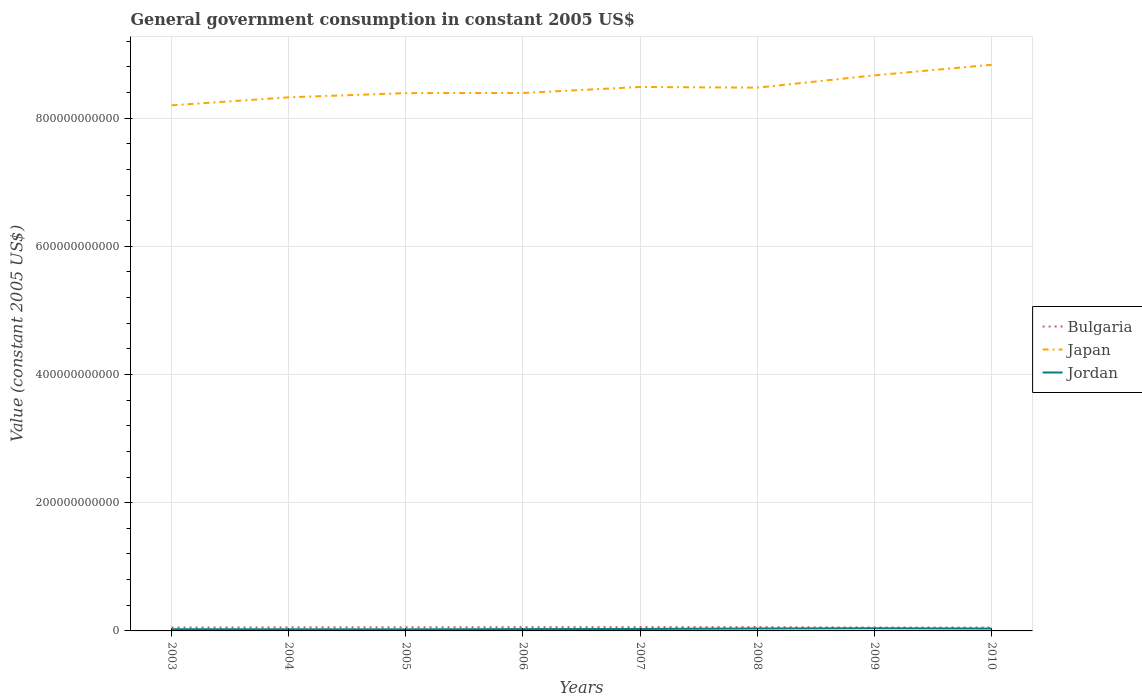Does the line corresponding to Bulgaria intersect with the line corresponding to Japan?
Offer a terse response. No. Is the number of lines equal to the number of legend labels?
Make the answer very short. Yes. Across all years, what is the maximum government conusmption in Bulgaria?
Keep it short and to the point. 5.26e+09. What is the total government conusmption in Japan in the graph?
Give a very brief answer. -1.64e+1. What is the difference between the highest and the second highest government conusmption in Jordan?
Keep it short and to the point. 1.69e+09. What is the difference between the highest and the lowest government conusmption in Japan?
Offer a terse response. 4. Is the government conusmption in Jordan strictly greater than the government conusmption in Bulgaria over the years?
Provide a succinct answer. Yes. What is the difference between two consecutive major ticks on the Y-axis?
Ensure brevity in your answer.  2.00e+11. Are the values on the major ticks of Y-axis written in scientific E-notation?
Offer a very short reply. No. Where does the legend appear in the graph?
Offer a terse response. Center right. What is the title of the graph?
Ensure brevity in your answer.  General government consumption in constant 2005 US$. Does "Georgia" appear as one of the legend labels in the graph?
Provide a short and direct response. No. What is the label or title of the X-axis?
Ensure brevity in your answer.  Years. What is the label or title of the Y-axis?
Your answer should be very brief. Value (constant 2005 US$). What is the Value (constant 2005 US$) of Bulgaria in 2003?
Give a very brief answer. 5.26e+09. What is the Value (constant 2005 US$) of Japan in 2003?
Provide a short and direct response. 8.20e+11. What is the Value (constant 2005 US$) of Jordan in 2003?
Provide a succinct answer. 2.63e+09. What is the Value (constant 2005 US$) of Bulgaria in 2004?
Give a very brief answer. 5.54e+09. What is the Value (constant 2005 US$) of Japan in 2004?
Your answer should be compact. 8.32e+11. What is the Value (constant 2005 US$) of Jordan in 2004?
Provide a succinct answer. 2.52e+09. What is the Value (constant 2005 US$) of Bulgaria in 2005?
Provide a short and direct response. 5.61e+09. What is the Value (constant 2005 US$) of Japan in 2005?
Your response must be concise. 8.39e+11. What is the Value (constant 2005 US$) in Jordan in 2005?
Your answer should be compact. 2.46e+09. What is the Value (constant 2005 US$) of Bulgaria in 2006?
Keep it short and to the point. 5.89e+09. What is the Value (constant 2005 US$) of Japan in 2006?
Your answer should be compact. 8.39e+11. What is the Value (constant 2005 US$) in Jordan in 2006?
Your answer should be very brief. 2.83e+09. What is the Value (constant 2005 US$) of Bulgaria in 2007?
Ensure brevity in your answer.  5.94e+09. What is the Value (constant 2005 US$) of Japan in 2007?
Offer a very short reply. 8.49e+11. What is the Value (constant 2005 US$) in Jordan in 2007?
Provide a succinct answer. 3.04e+09. What is the Value (constant 2005 US$) in Bulgaria in 2008?
Your answer should be very brief. 5.93e+09. What is the Value (constant 2005 US$) of Japan in 2008?
Keep it short and to the point. 8.47e+11. What is the Value (constant 2005 US$) of Jordan in 2008?
Make the answer very short. 3.76e+09. What is the Value (constant 2005 US$) of Bulgaria in 2009?
Make the answer very short. 5.37e+09. What is the Value (constant 2005 US$) in Japan in 2009?
Make the answer very short. 8.67e+11. What is the Value (constant 2005 US$) of Jordan in 2009?
Keep it short and to the point. 4.15e+09. What is the Value (constant 2005 US$) in Bulgaria in 2010?
Provide a succinct answer. 5.27e+09. What is the Value (constant 2005 US$) in Japan in 2010?
Your response must be concise. 8.83e+11. What is the Value (constant 2005 US$) in Jordan in 2010?
Provide a short and direct response. 3.68e+09. Across all years, what is the maximum Value (constant 2005 US$) of Bulgaria?
Ensure brevity in your answer.  5.94e+09. Across all years, what is the maximum Value (constant 2005 US$) in Japan?
Make the answer very short. 8.83e+11. Across all years, what is the maximum Value (constant 2005 US$) of Jordan?
Your response must be concise. 4.15e+09. Across all years, what is the minimum Value (constant 2005 US$) of Bulgaria?
Keep it short and to the point. 5.26e+09. Across all years, what is the minimum Value (constant 2005 US$) in Japan?
Your response must be concise. 8.20e+11. Across all years, what is the minimum Value (constant 2005 US$) of Jordan?
Your answer should be very brief. 2.46e+09. What is the total Value (constant 2005 US$) of Bulgaria in the graph?
Your answer should be very brief. 4.48e+1. What is the total Value (constant 2005 US$) in Japan in the graph?
Give a very brief answer. 6.78e+12. What is the total Value (constant 2005 US$) in Jordan in the graph?
Give a very brief answer. 2.51e+1. What is the difference between the Value (constant 2005 US$) in Bulgaria in 2003 and that in 2004?
Make the answer very short. -2.78e+08. What is the difference between the Value (constant 2005 US$) in Japan in 2003 and that in 2004?
Offer a terse response. -1.25e+1. What is the difference between the Value (constant 2005 US$) in Jordan in 2003 and that in 2004?
Make the answer very short. 1.10e+08. What is the difference between the Value (constant 2005 US$) in Bulgaria in 2003 and that in 2005?
Keep it short and to the point. -3.56e+08. What is the difference between the Value (constant 2005 US$) of Japan in 2003 and that in 2005?
Your response must be concise. -1.90e+1. What is the difference between the Value (constant 2005 US$) in Jordan in 2003 and that in 2005?
Provide a succinct answer. 1.72e+08. What is the difference between the Value (constant 2005 US$) in Bulgaria in 2003 and that in 2006?
Provide a short and direct response. -6.34e+08. What is the difference between the Value (constant 2005 US$) in Japan in 2003 and that in 2006?
Give a very brief answer. -1.93e+1. What is the difference between the Value (constant 2005 US$) in Jordan in 2003 and that in 2006?
Keep it short and to the point. -2.01e+08. What is the difference between the Value (constant 2005 US$) in Bulgaria in 2003 and that in 2007?
Offer a terse response. -6.83e+08. What is the difference between the Value (constant 2005 US$) of Japan in 2003 and that in 2007?
Make the answer very short. -2.86e+1. What is the difference between the Value (constant 2005 US$) in Jordan in 2003 and that in 2007?
Ensure brevity in your answer.  -4.11e+08. What is the difference between the Value (constant 2005 US$) of Bulgaria in 2003 and that in 2008?
Your answer should be compact. -6.74e+08. What is the difference between the Value (constant 2005 US$) in Japan in 2003 and that in 2008?
Your response must be concise. -2.75e+1. What is the difference between the Value (constant 2005 US$) in Jordan in 2003 and that in 2008?
Provide a short and direct response. -1.13e+09. What is the difference between the Value (constant 2005 US$) in Bulgaria in 2003 and that in 2009?
Make the answer very short. -1.13e+08. What is the difference between the Value (constant 2005 US$) of Japan in 2003 and that in 2009?
Your answer should be compact. -4.68e+1. What is the difference between the Value (constant 2005 US$) of Jordan in 2003 and that in 2009?
Provide a succinct answer. -1.52e+09. What is the difference between the Value (constant 2005 US$) of Bulgaria in 2003 and that in 2010?
Your answer should be compact. -8.52e+06. What is the difference between the Value (constant 2005 US$) in Japan in 2003 and that in 2010?
Your response must be concise. -6.32e+1. What is the difference between the Value (constant 2005 US$) in Jordan in 2003 and that in 2010?
Offer a terse response. -1.05e+09. What is the difference between the Value (constant 2005 US$) in Bulgaria in 2004 and that in 2005?
Offer a very short reply. -7.82e+07. What is the difference between the Value (constant 2005 US$) of Japan in 2004 and that in 2005?
Your answer should be compact. -6.57e+09. What is the difference between the Value (constant 2005 US$) in Jordan in 2004 and that in 2005?
Make the answer very short. 6.21e+07. What is the difference between the Value (constant 2005 US$) in Bulgaria in 2004 and that in 2006?
Your answer should be very brief. -3.56e+08. What is the difference between the Value (constant 2005 US$) in Japan in 2004 and that in 2006?
Your answer should be compact. -6.80e+09. What is the difference between the Value (constant 2005 US$) of Jordan in 2004 and that in 2006?
Your answer should be compact. -3.11e+08. What is the difference between the Value (constant 2005 US$) of Bulgaria in 2004 and that in 2007?
Keep it short and to the point. -4.04e+08. What is the difference between the Value (constant 2005 US$) in Japan in 2004 and that in 2007?
Keep it short and to the point. -1.61e+1. What is the difference between the Value (constant 2005 US$) in Jordan in 2004 and that in 2007?
Give a very brief answer. -5.21e+08. What is the difference between the Value (constant 2005 US$) in Bulgaria in 2004 and that in 2008?
Provide a succinct answer. -3.95e+08. What is the difference between the Value (constant 2005 US$) in Japan in 2004 and that in 2008?
Your response must be concise. -1.51e+1. What is the difference between the Value (constant 2005 US$) of Jordan in 2004 and that in 2008?
Offer a terse response. -1.24e+09. What is the difference between the Value (constant 2005 US$) in Bulgaria in 2004 and that in 2009?
Offer a very short reply. 1.65e+08. What is the difference between the Value (constant 2005 US$) in Japan in 2004 and that in 2009?
Provide a short and direct response. -3.43e+1. What is the difference between the Value (constant 2005 US$) of Jordan in 2004 and that in 2009?
Give a very brief answer. -1.63e+09. What is the difference between the Value (constant 2005 US$) of Bulgaria in 2004 and that in 2010?
Keep it short and to the point. 2.70e+08. What is the difference between the Value (constant 2005 US$) in Japan in 2004 and that in 2010?
Provide a short and direct response. -5.07e+1. What is the difference between the Value (constant 2005 US$) of Jordan in 2004 and that in 2010?
Give a very brief answer. -1.16e+09. What is the difference between the Value (constant 2005 US$) in Bulgaria in 2005 and that in 2006?
Your response must be concise. -2.78e+08. What is the difference between the Value (constant 2005 US$) in Japan in 2005 and that in 2006?
Provide a short and direct response. -2.30e+08. What is the difference between the Value (constant 2005 US$) in Jordan in 2005 and that in 2006?
Give a very brief answer. -3.73e+08. What is the difference between the Value (constant 2005 US$) of Bulgaria in 2005 and that in 2007?
Your answer should be very brief. -3.26e+08. What is the difference between the Value (constant 2005 US$) in Japan in 2005 and that in 2007?
Give a very brief answer. -9.56e+09. What is the difference between the Value (constant 2005 US$) in Jordan in 2005 and that in 2007?
Your answer should be compact. -5.83e+08. What is the difference between the Value (constant 2005 US$) of Bulgaria in 2005 and that in 2008?
Provide a succinct answer. -3.17e+08. What is the difference between the Value (constant 2005 US$) in Japan in 2005 and that in 2008?
Provide a short and direct response. -8.49e+09. What is the difference between the Value (constant 2005 US$) of Jordan in 2005 and that in 2008?
Offer a terse response. -1.30e+09. What is the difference between the Value (constant 2005 US$) of Bulgaria in 2005 and that in 2009?
Make the answer very short. 2.44e+08. What is the difference between the Value (constant 2005 US$) in Japan in 2005 and that in 2009?
Give a very brief answer. -2.77e+1. What is the difference between the Value (constant 2005 US$) in Jordan in 2005 and that in 2009?
Make the answer very short. -1.69e+09. What is the difference between the Value (constant 2005 US$) in Bulgaria in 2005 and that in 2010?
Offer a terse response. 3.48e+08. What is the difference between the Value (constant 2005 US$) in Japan in 2005 and that in 2010?
Make the answer very short. -4.42e+1. What is the difference between the Value (constant 2005 US$) in Jordan in 2005 and that in 2010?
Make the answer very short. -1.22e+09. What is the difference between the Value (constant 2005 US$) in Bulgaria in 2006 and that in 2007?
Provide a succinct answer. -4.85e+07. What is the difference between the Value (constant 2005 US$) in Japan in 2006 and that in 2007?
Your response must be concise. -9.33e+09. What is the difference between the Value (constant 2005 US$) in Jordan in 2006 and that in 2007?
Provide a succinct answer. -2.10e+08. What is the difference between the Value (constant 2005 US$) of Bulgaria in 2006 and that in 2008?
Offer a very short reply. -3.97e+07. What is the difference between the Value (constant 2005 US$) in Japan in 2006 and that in 2008?
Offer a terse response. -8.26e+09. What is the difference between the Value (constant 2005 US$) in Jordan in 2006 and that in 2008?
Your answer should be very brief. -9.28e+08. What is the difference between the Value (constant 2005 US$) in Bulgaria in 2006 and that in 2009?
Give a very brief answer. 5.21e+08. What is the difference between the Value (constant 2005 US$) of Japan in 2006 and that in 2009?
Ensure brevity in your answer.  -2.75e+1. What is the difference between the Value (constant 2005 US$) of Jordan in 2006 and that in 2009?
Offer a terse response. -1.32e+09. What is the difference between the Value (constant 2005 US$) in Bulgaria in 2006 and that in 2010?
Your response must be concise. 6.25e+08. What is the difference between the Value (constant 2005 US$) of Japan in 2006 and that in 2010?
Provide a short and direct response. -4.39e+1. What is the difference between the Value (constant 2005 US$) in Jordan in 2006 and that in 2010?
Offer a very short reply. -8.51e+08. What is the difference between the Value (constant 2005 US$) in Bulgaria in 2007 and that in 2008?
Ensure brevity in your answer.  8.86e+06. What is the difference between the Value (constant 2005 US$) in Japan in 2007 and that in 2008?
Ensure brevity in your answer.  1.07e+09. What is the difference between the Value (constant 2005 US$) in Jordan in 2007 and that in 2008?
Your answer should be compact. -7.18e+08. What is the difference between the Value (constant 2005 US$) in Bulgaria in 2007 and that in 2009?
Keep it short and to the point. 5.70e+08. What is the difference between the Value (constant 2005 US$) in Japan in 2007 and that in 2009?
Ensure brevity in your answer.  -1.82e+1. What is the difference between the Value (constant 2005 US$) in Jordan in 2007 and that in 2009?
Provide a short and direct response. -1.11e+09. What is the difference between the Value (constant 2005 US$) of Bulgaria in 2007 and that in 2010?
Give a very brief answer. 6.74e+08. What is the difference between the Value (constant 2005 US$) in Japan in 2007 and that in 2010?
Offer a very short reply. -3.46e+1. What is the difference between the Value (constant 2005 US$) in Jordan in 2007 and that in 2010?
Your answer should be very brief. -6.41e+08. What is the difference between the Value (constant 2005 US$) in Bulgaria in 2008 and that in 2009?
Ensure brevity in your answer.  5.61e+08. What is the difference between the Value (constant 2005 US$) in Japan in 2008 and that in 2009?
Your answer should be compact. -1.92e+1. What is the difference between the Value (constant 2005 US$) in Jordan in 2008 and that in 2009?
Your answer should be compact. -3.93e+08. What is the difference between the Value (constant 2005 US$) in Bulgaria in 2008 and that in 2010?
Offer a terse response. 6.65e+08. What is the difference between the Value (constant 2005 US$) in Japan in 2008 and that in 2010?
Give a very brief answer. -3.57e+1. What is the difference between the Value (constant 2005 US$) in Jordan in 2008 and that in 2010?
Make the answer very short. 7.65e+07. What is the difference between the Value (constant 2005 US$) in Bulgaria in 2009 and that in 2010?
Provide a short and direct response. 1.04e+08. What is the difference between the Value (constant 2005 US$) of Japan in 2009 and that in 2010?
Ensure brevity in your answer.  -1.64e+1. What is the difference between the Value (constant 2005 US$) of Jordan in 2009 and that in 2010?
Offer a very short reply. 4.69e+08. What is the difference between the Value (constant 2005 US$) in Bulgaria in 2003 and the Value (constant 2005 US$) in Japan in 2004?
Make the answer very short. -8.27e+11. What is the difference between the Value (constant 2005 US$) in Bulgaria in 2003 and the Value (constant 2005 US$) in Jordan in 2004?
Make the answer very short. 2.74e+09. What is the difference between the Value (constant 2005 US$) of Japan in 2003 and the Value (constant 2005 US$) of Jordan in 2004?
Offer a very short reply. 8.17e+11. What is the difference between the Value (constant 2005 US$) of Bulgaria in 2003 and the Value (constant 2005 US$) of Japan in 2005?
Your answer should be compact. -8.34e+11. What is the difference between the Value (constant 2005 US$) in Bulgaria in 2003 and the Value (constant 2005 US$) in Jordan in 2005?
Make the answer very short. 2.80e+09. What is the difference between the Value (constant 2005 US$) in Japan in 2003 and the Value (constant 2005 US$) in Jordan in 2005?
Your response must be concise. 8.17e+11. What is the difference between the Value (constant 2005 US$) of Bulgaria in 2003 and the Value (constant 2005 US$) of Japan in 2006?
Keep it short and to the point. -8.34e+11. What is the difference between the Value (constant 2005 US$) of Bulgaria in 2003 and the Value (constant 2005 US$) of Jordan in 2006?
Offer a terse response. 2.43e+09. What is the difference between the Value (constant 2005 US$) in Japan in 2003 and the Value (constant 2005 US$) in Jordan in 2006?
Provide a short and direct response. 8.17e+11. What is the difference between the Value (constant 2005 US$) in Bulgaria in 2003 and the Value (constant 2005 US$) in Japan in 2007?
Provide a succinct answer. -8.43e+11. What is the difference between the Value (constant 2005 US$) of Bulgaria in 2003 and the Value (constant 2005 US$) of Jordan in 2007?
Provide a short and direct response. 2.22e+09. What is the difference between the Value (constant 2005 US$) of Japan in 2003 and the Value (constant 2005 US$) of Jordan in 2007?
Provide a short and direct response. 8.17e+11. What is the difference between the Value (constant 2005 US$) of Bulgaria in 2003 and the Value (constant 2005 US$) of Japan in 2008?
Provide a succinct answer. -8.42e+11. What is the difference between the Value (constant 2005 US$) in Bulgaria in 2003 and the Value (constant 2005 US$) in Jordan in 2008?
Your answer should be compact. 1.50e+09. What is the difference between the Value (constant 2005 US$) in Japan in 2003 and the Value (constant 2005 US$) in Jordan in 2008?
Provide a short and direct response. 8.16e+11. What is the difference between the Value (constant 2005 US$) in Bulgaria in 2003 and the Value (constant 2005 US$) in Japan in 2009?
Offer a very short reply. -8.61e+11. What is the difference between the Value (constant 2005 US$) in Bulgaria in 2003 and the Value (constant 2005 US$) in Jordan in 2009?
Ensure brevity in your answer.  1.11e+09. What is the difference between the Value (constant 2005 US$) of Japan in 2003 and the Value (constant 2005 US$) of Jordan in 2009?
Keep it short and to the point. 8.16e+11. What is the difference between the Value (constant 2005 US$) in Bulgaria in 2003 and the Value (constant 2005 US$) in Japan in 2010?
Make the answer very short. -8.78e+11. What is the difference between the Value (constant 2005 US$) of Bulgaria in 2003 and the Value (constant 2005 US$) of Jordan in 2010?
Ensure brevity in your answer.  1.58e+09. What is the difference between the Value (constant 2005 US$) in Japan in 2003 and the Value (constant 2005 US$) in Jordan in 2010?
Your answer should be compact. 8.16e+11. What is the difference between the Value (constant 2005 US$) in Bulgaria in 2004 and the Value (constant 2005 US$) in Japan in 2005?
Give a very brief answer. -8.33e+11. What is the difference between the Value (constant 2005 US$) of Bulgaria in 2004 and the Value (constant 2005 US$) of Jordan in 2005?
Your answer should be compact. 3.08e+09. What is the difference between the Value (constant 2005 US$) in Japan in 2004 and the Value (constant 2005 US$) in Jordan in 2005?
Your response must be concise. 8.30e+11. What is the difference between the Value (constant 2005 US$) in Bulgaria in 2004 and the Value (constant 2005 US$) in Japan in 2006?
Your response must be concise. -8.34e+11. What is the difference between the Value (constant 2005 US$) of Bulgaria in 2004 and the Value (constant 2005 US$) of Jordan in 2006?
Provide a succinct answer. 2.70e+09. What is the difference between the Value (constant 2005 US$) of Japan in 2004 and the Value (constant 2005 US$) of Jordan in 2006?
Offer a very short reply. 8.30e+11. What is the difference between the Value (constant 2005 US$) in Bulgaria in 2004 and the Value (constant 2005 US$) in Japan in 2007?
Make the answer very short. -8.43e+11. What is the difference between the Value (constant 2005 US$) of Bulgaria in 2004 and the Value (constant 2005 US$) of Jordan in 2007?
Your answer should be very brief. 2.49e+09. What is the difference between the Value (constant 2005 US$) in Japan in 2004 and the Value (constant 2005 US$) in Jordan in 2007?
Your answer should be compact. 8.29e+11. What is the difference between the Value (constant 2005 US$) of Bulgaria in 2004 and the Value (constant 2005 US$) of Japan in 2008?
Offer a terse response. -8.42e+11. What is the difference between the Value (constant 2005 US$) in Bulgaria in 2004 and the Value (constant 2005 US$) in Jordan in 2008?
Provide a short and direct response. 1.78e+09. What is the difference between the Value (constant 2005 US$) in Japan in 2004 and the Value (constant 2005 US$) in Jordan in 2008?
Your answer should be compact. 8.29e+11. What is the difference between the Value (constant 2005 US$) of Bulgaria in 2004 and the Value (constant 2005 US$) of Japan in 2009?
Your answer should be compact. -8.61e+11. What is the difference between the Value (constant 2005 US$) of Bulgaria in 2004 and the Value (constant 2005 US$) of Jordan in 2009?
Provide a short and direct response. 1.38e+09. What is the difference between the Value (constant 2005 US$) of Japan in 2004 and the Value (constant 2005 US$) of Jordan in 2009?
Give a very brief answer. 8.28e+11. What is the difference between the Value (constant 2005 US$) of Bulgaria in 2004 and the Value (constant 2005 US$) of Japan in 2010?
Offer a terse response. -8.78e+11. What is the difference between the Value (constant 2005 US$) in Bulgaria in 2004 and the Value (constant 2005 US$) in Jordan in 2010?
Provide a short and direct response. 1.85e+09. What is the difference between the Value (constant 2005 US$) of Japan in 2004 and the Value (constant 2005 US$) of Jordan in 2010?
Provide a succinct answer. 8.29e+11. What is the difference between the Value (constant 2005 US$) in Bulgaria in 2005 and the Value (constant 2005 US$) in Japan in 2006?
Your answer should be very brief. -8.34e+11. What is the difference between the Value (constant 2005 US$) in Bulgaria in 2005 and the Value (constant 2005 US$) in Jordan in 2006?
Provide a short and direct response. 2.78e+09. What is the difference between the Value (constant 2005 US$) in Japan in 2005 and the Value (constant 2005 US$) in Jordan in 2006?
Offer a terse response. 8.36e+11. What is the difference between the Value (constant 2005 US$) in Bulgaria in 2005 and the Value (constant 2005 US$) in Japan in 2007?
Make the answer very short. -8.43e+11. What is the difference between the Value (constant 2005 US$) of Bulgaria in 2005 and the Value (constant 2005 US$) of Jordan in 2007?
Your response must be concise. 2.57e+09. What is the difference between the Value (constant 2005 US$) in Japan in 2005 and the Value (constant 2005 US$) in Jordan in 2007?
Your response must be concise. 8.36e+11. What is the difference between the Value (constant 2005 US$) of Bulgaria in 2005 and the Value (constant 2005 US$) of Japan in 2008?
Give a very brief answer. -8.42e+11. What is the difference between the Value (constant 2005 US$) in Bulgaria in 2005 and the Value (constant 2005 US$) in Jordan in 2008?
Offer a very short reply. 1.86e+09. What is the difference between the Value (constant 2005 US$) of Japan in 2005 and the Value (constant 2005 US$) of Jordan in 2008?
Offer a terse response. 8.35e+11. What is the difference between the Value (constant 2005 US$) of Bulgaria in 2005 and the Value (constant 2005 US$) of Japan in 2009?
Offer a terse response. -8.61e+11. What is the difference between the Value (constant 2005 US$) of Bulgaria in 2005 and the Value (constant 2005 US$) of Jordan in 2009?
Your response must be concise. 1.46e+09. What is the difference between the Value (constant 2005 US$) in Japan in 2005 and the Value (constant 2005 US$) in Jordan in 2009?
Provide a short and direct response. 8.35e+11. What is the difference between the Value (constant 2005 US$) of Bulgaria in 2005 and the Value (constant 2005 US$) of Japan in 2010?
Your response must be concise. -8.77e+11. What is the difference between the Value (constant 2005 US$) in Bulgaria in 2005 and the Value (constant 2005 US$) in Jordan in 2010?
Your response must be concise. 1.93e+09. What is the difference between the Value (constant 2005 US$) of Japan in 2005 and the Value (constant 2005 US$) of Jordan in 2010?
Make the answer very short. 8.35e+11. What is the difference between the Value (constant 2005 US$) in Bulgaria in 2006 and the Value (constant 2005 US$) in Japan in 2007?
Ensure brevity in your answer.  -8.43e+11. What is the difference between the Value (constant 2005 US$) of Bulgaria in 2006 and the Value (constant 2005 US$) of Jordan in 2007?
Provide a short and direct response. 2.85e+09. What is the difference between the Value (constant 2005 US$) of Japan in 2006 and the Value (constant 2005 US$) of Jordan in 2007?
Your answer should be compact. 8.36e+11. What is the difference between the Value (constant 2005 US$) of Bulgaria in 2006 and the Value (constant 2005 US$) of Japan in 2008?
Keep it short and to the point. -8.42e+11. What is the difference between the Value (constant 2005 US$) in Bulgaria in 2006 and the Value (constant 2005 US$) in Jordan in 2008?
Your answer should be compact. 2.13e+09. What is the difference between the Value (constant 2005 US$) in Japan in 2006 and the Value (constant 2005 US$) in Jordan in 2008?
Ensure brevity in your answer.  8.35e+11. What is the difference between the Value (constant 2005 US$) of Bulgaria in 2006 and the Value (constant 2005 US$) of Japan in 2009?
Provide a short and direct response. -8.61e+11. What is the difference between the Value (constant 2005 US$) in Bulgaria in 2006 and the Value (constant 2005 US$) in Jordan in 2009?
Provide a short and direct response. 1.74e+09. What is the difference between the Value (constant 2005 US$) of Japan in 2006 and the Value (constant 2005 US$) of Jordan in 2009?
Provide a succinct answer. 8.35e+11. What is the difference between the Value (constant 2005 US$) of Bulgaria in 2006 and the Value (constant 2005 US$) of Japan in 2010?
Your answer should be compact. -8.77e+11. What is the difference between the Value (constant 2005 US$) of Bulgaria in 2006 and the Value (constant 2005 US$) of Jordan in 2010?
Your answer should be compact. 2.21e+09. What is the difference between the Value (constant 2005 US$) of Japan in 2006 and the Value (constant 2005 US$) of Jordan in 2010?
Give a very brief answer. 8.36e+11. What is the difference between the Value (constant 2005 US$) of Bulgaria in 2007 and the Value (constant 2005 US$) of Japan in 2008?
Provide a succinct answer. -8.41e+11. What is the difference between the Value (constant 2005 US$) in Bulgaria in 2007 and the Value (constant 2005 US$) in Jordan in 2008?
Make the answer very short. 2.18e+09. What is the difference between the Value (constant 2005 US$) of Japan in 2007 and the Value (constant 2005 US$) of Jordan in 2008?
Offer a terse response. 8.45e+11. What is the difference between the Value (constant 2005 US$) in Bulgaria in 2007 and the Value (constant 2005 US$) in Japan in 2009?
Keep it short and to the point. -8.61e+11. What is the difference between the Value (constant 2005 US$) in Bulgaria in 2007 and the Value (constant 2005 US$) in Jordan in 2009?
Your answer should be compact. 1.79e+09. What is the difference between the Value (constant 2005 US$) in Japan in 2007 and the Value (constant 2005 US$) in Jordan in 2009?
Keep it short and to the point. 8.44e+11. What is the difference between the Value (constant 2005 US$) of Bulgaria in 2007 and the Value (constant 2005 US$) of Japan in 2010?
Give a very brief answer. -8.77e+11. What is the difference between the Value (constant 2005 US$) of Bulgaria in 2007 and the Value (constant 2005 US$) of Jordan in 2010?
Offer a terse response. 2.26e+09. What is the difference between the Value (constant 2005 US$) of Japan in 2007 and the Value (constant 2005 US$) of Jordan in 2010?
Keep it short and to the point. 8.45e+11. What is the difference between the Value (constant 2005 US$) of Bulgaria in 2008 and the Value (constant 2005 US$) of Japan in 2009?
Your response must be concise. -8.61e+11. What is the difference between the Value (constant 2005 US$) in Bulgaria in 2008 and the Value (constant 2005 US$) in Jordan in 2009?
Your answer should be very brief. 1.78e+09. What is the difference between the Value (constant 2005 US$) of Japan in 2008 and the Value (constant 2005 US$) of Jordan in 2009?
Make the answer very short. 8.43e+11. What is the difference between the Value (constant 2005 US$) of Bulgaria in 2008 and the Value (constant 2005 US$) of Japan in 2010?
Keep it short and to the point. -8.77e+11. What is the difference between the Value (constant 2005 US$) of Bulgaria in 2008 and the Value (constant 2005 US$) of Jordan in 2010?
Your answer should be compact. 2.25e+09. What is the difference between the Value (constant 2005 US$) in Japan in 2008 and the Value (constant 2005 US$) in Jordan in 2010?
Your answer should be compact. 8.44e+11. What is the difference between the Value (constant 2005 US$) in Bulgaria in 2009 and the Value (constant 2005 US$) in Japan in 2010?
Offer a terse response. -8.78e+11. What is the difference between the Value (constant 2005 US$) in Bulgaria in 2009 and the Value (constant 2005 US$) in Jordan in 2010?
Provide a succinct answer. 1.69e+09. What is the difference between the Value (constant 2005 US$) in Japan in 2009 and the Value (constant 2005 US$) in Jordan in 2010?
Provide a short and direct response. 8.63e+11. What is the average Value (constant 2005 US$) of Bulgaria per year?
Your answer should be compact. 5.60e+09. What is the average Value (constant 2005 US$) of Japan per year?
Make the answer very short. 8.47e+11. What is the average Value (constant 2005 US$) in Jordan per year?
Ensure brevity in your answer.  3.13e+09. In the year 2003, what is the difference between the Value (constant 2005 US$) of Bulgaria and Value (constant 2005 US$) of Japan?
Your response must be concise. -8.15e+11. In the year 2003, what is the difference between the Value (constant 2005 US$) in Bulgaria and Value (constant 2005 US$) in Jordan?
Ensure brevity in your answer.  2.63e+09. In the year 2003, what is the difference between the Value (constant 2005 US$) of Japan and Value (constant 2005 US$) of Jordan?
Offer a very short reply. 8.17e+11. In the year 2004, what is the difference between the Value (constant 2005 US$) in Bulgaria and Value (constant 2005 US$) in Japan?
Ensure brevity in your answer.  -8.27e+11. In the year 2004, what is the difference between the Value (constant 2005 US$) in Bulgaria and Value (constant 2005 US$) in Jordan?
Keep it short and to the point. 3.02e+09. In the year 2004, what is the difference between the Value (constant 2005 US$) in Japan and Value (constant 2005 US$) in Jordan?
Provide a succinct answer. 8.30e+11. In the year 2005, what is the difference between the Value (constant 2005 US$) of Bulgaria and Value (constant 2005 US$) of Japan?
Give a very brief answer. -8.33e+11. In the year 2005, what is the difference between the Value (constant 2005 US$) in Bulgaria and Value (constant 2005 US$) in Jordan?
Your answer should be compact. 3.16e+09. In the year 2005, what is the difference between the Value (constant 2005 US$) of Japan and Value (constant 2005 US$) of Jordan?
Your response must be concise. 8.36e+11. In the year 2006, what is the difference between the Value (constant 2005 US$) of Bulgaria and Value (constant 2005 US$) of Japan?
Offer a terse response. -8.33e+11. In the year 2006, what is the difference between the Value (constant 2005 US$) of Bulgaria and Value (constant 2005 US$) of Jordan?
Offer a very short reply. 3.06e+09. In the year 2006, what is the difference between the Value (constant 2005 US$) of Japan and Value (constant 2005 US$) of Jordan?
Your answer should be compact. 8.36e+11. In the year 2007, what is the difference between the Value (constant 2005 US$) of Bulgaria and Value (constant 2005 US$) of Japan?
Your response must be concise. -8.43e+11. In the year 2007, what is the difference between the Value (constant 2005 US$) in Bulgaria and Value (constant 2005 US$) in Jordan?
Your answer should be compact. 2.90e+09. In the year 2007, what is the difference between the Value (constant 2005 US$) in Japan and Value (constant 2005 US$) in Jordan?
Offer a very short reply. 8.45e+11. In the year 2008, what is the difference between the Value (constant 2005 US$) in Bulgaria and Value (constant 2005 US$) in Japan?
Your response must be concise. -8.42e+11. In the year 2008, what is the difference between the Value (constant 2005 US$) in Bulgaria and Value (constant 2005 US$) in Jordan?
Offer a terse response. 2.17e+09. In the year 2008, what is the difference between the Value (constant 2005 US$) of Japan and Value (constant 2005 US$) of Jordan?
Your answer should be very brief. 8.44e+11. In the year 2009, what is the difference between the Value (constant 2005 US$) of Bulgaria and Value (constant 2005 US$) of Japan?
Your answer should be very brief. -8.61e+11. In the year 2009, what is the difference between the Value (constant 2005 US$) in Bulgaria and Value (constant 2005 US$) in Jordan?
Keep it short and to the point. 1.22e+09. In the year 2009, what is the difference between the Value (constant 2005 US$) of Japan and Value (constant 2005 US$) of Jordan?
Offer a terse response. 8.63e+11. In the year 2010, what is the difference between the Value (constant 2005 US$) in Bulgaria and Value (constant 2005 US$) in Japan?
Offer a very short reply. -8.78e+11. In the year 2010, what is the difference between the Value (constant 2005 US$) of Bulgaria and Value (constant 2005 US$) of Jordan?
Offer a terse response. 1.58e+09. In the year 2010, what is the difference between the Value (constant 2005 US$) in Japan and Value (constant 2005 US$) in Jordan?
Ensure brevity in your answer.  8.79e+11. What is the ratio of the Value (constant 2005 US$) in Bulgaria in 2003 to that in 2004?
Provide a succinct answer. 0.95. What is the ratio of the Value (constant 2005 US$) of Japan in 2003 to that in 2004?
Provide a short and direct response. 0.98. What is the ratio of the Value (constant 2005 US$) in Jordan in 2003 to that in 2004?
Offer a terse response. 1.04. What is the ratio of the Value (constant 2005 US$) of Bulgaria in 2003 to that in 2005?
Offer a very short reply. 0.94. What is the ratio of the Value (constant 2005 US$) of Japan in 2003 to that in 2005?
Keep it short and to the point. 0.98. What is the ratio of the Value (constant 2005 US$) in Jordan in 2003 to that in 2005?
Offer a very short reply. 1.07. What is the ratio of the Value (constant 2005 US$) in Bulgaria in 2003 to that in 2006?
Make the answer very short. 0.89. What is the ratio of the Value (constant 2005 US$) of Jordan in 2003 to that in 2006?
Make the answer very short. 0.93. What is the ratio of the Value (constant 2005 US$) of Bulgaria in 2003 to that in 2007?
Give a very brief answer. 0.89. What is the ratio of the Value (constant 2005 US$) in Japan in 2003 to that in 2007?
Your response must be concise. 0.97. What is the ratio of the Value (constant 2005 US$) of Jordan in 2003 to that in 2007?
Your answer should be very brief. 0.86. What is the ratio of the Value (constant 2005 US$) of Bulgaria in 2003 to that in 2008?
Provide a short and direct response. 0.89. What is the ratio of the Value (constant 2005 US$) of Japan in 2003 to that in 2008?
Keep it short and to the point. 0.97. What is the ratio of the Value (constant 2005 US$) of Jordan in 2003 to that in 2008?
Your response must be concise. 0.7. What is the ratio of the Value (constant 2005 US$) in Japan in 2003 to that in 2009?
Your answer should be compact. 0.95. What is the ratio of the Value (constant 2005 US$) of Jordan in 2003 to that in 2009?
Provide a succinct answer. 0.63. What is the ratio of the Value (constant 2005 US$) of Bulgaria in 2003 to that in 2010?
Ensure brevity in your answer.  1. What is the ratio of the Value (constant 2005 US$) in Japan in 2003 to that in 2010?
Keep it short and to the point. 0.93. What is the ratio of the Value (constant 2005 US$) in Jordan in 2003 to that in 2010?
Your answer should be very brief. 0.71. What is the ratio of the Value (constant 2005 US$) of Bulgaria in 2004 to that in 2005?
Give a very brief answer. 0.99. What is the ratio of the Value (constant 2005 US$) of Japan in 2004 to that in 2005?
Ensure brevity in your answer.  0.99. What is the ratio of the Value (constant 2005 US$) in Jordan in 2004 to that in 2005?
Make the answer very short. 1.03. What is the ratio of the Value (constant 2005 US$) of Bulgaria in 2004 to that in 2006?
Your answer should be compact. 0.94. What is the ratio of the Value (constant 2005 US$) of Jordan in 2004 to that in 2006?
Your answer should be very brief. 0.89. What is the ratio of the Value (constant 2005 US$) of Bulgaria in 2004 to that in 2007?
Your answer should be very brief. 0.93. What is the ratio of the Value (constant 2005 US$) of Jordan in 2004 to that in 2007?
Provide a short and direct response. 0.83. What is the ratio of the Value (constant 2005 US$) of Bulgaria in 2004 to that in 2008?
Ensure brevity in your answer.  0.93. What is the ratio of the Value (constant 2005 US$) in Japan in 2004 to that in 2008?
Provide a short and direct response. 0.98. What is the ratio of the Value (constant 2005 US$) in Jordan in 2004 to that in 2008?
Your answer should be compact. 0.67. What is the ratio of the Value (constant 2005 US$) of Bulgaria in 2004 to that in 2009?
Offer a very short reply. 1.03. What is the ratio of the Value (constant 2005 US$) of Japan in 2004 to that in 2009?
Provide a short and direct response. 0.96. What is the ratio of the Value (constant 2005 US$) of Jordan in 2004 to that in 2009?
Ensure brevity in your answer.  0.61. What is the ratio of the Value (constant 2005 US$) of Bulgaria in 2004 to that in 2010?
Offer a terse response. 1.05. What is the ratio of the Value (constant 2005 US$) of Japan in 2004 to that in 2010?
Offer a terse response. 0.94. What is the ratio of the Value (constant 2005 US$) of Jordan in 2004 to that in 2010?
Provide a short and direct response. 0.68. What is the ratio of the Value (constant 2005 US$) in Bulgaria in 2005 to that in 2006?
Offer a very short reply. 0.95. What is the ratio of the Value (constant 2005 US$) of Japan in 2005 to that in 2006?
Your answer should be compact. 1. What is the ratio of the Value (constant 2005 US$) in Jordan in 2005 to that in 2006?
Your answer should be compact. 0.87. What is the ratio of the Value (constant 2005 US$) in Bulgaria in 2005 to that in 2007?
Your answer should be very brief. 0.95. What is the ratio of the Value (constant 2005 US$) in Japan in 2005 to that in 2007?
Your answer should be compact. 0.99. What is the ratio of the Value (constant 2005 US$) of Jordan in 2005 to that in 2007?
Offer a terse response. 0.81. What is the ratio of the Value (constant 2005 US$) in Bulgaria in 2005 to that in 2008?
Give a very brief answer. 0.95. What is the ratio of the Value (constant 2005 US$) in Japan in 2005 to that in 2008?
Your answer should be very brief. 0.99. What is the ratio of the Value (constant 2005 US$) of Jordan in 2005 to that in 2008?
Your answer should be compact. 0.65. What is the ratio of the Value (constant 2005 US$) in Bulgaria in 2005 to that in 2009?
Offer a very short reply. 1.05. What is the ratio of the Value (constant 2005 US$) in Jordan in 2005 to that in 2009?
Offer a terse response. 0.59. What is the ratio of the Value (constant 2005 US$) of Bulgaria in 2005 to that in 2010?
Provide a short and direct response. 1.07. What is the ratio of the Value (constant 2005 US$) in Jordan in 2005 to that in 2010?
Give a very brief answer. 0.67. What is the ratio of the Value (constant 2005 US$) of Japan in 2006 to that in 2007?
Keep it short and to the point. 0.99. What is the ratio of the Value (constant 2005 US$) in Jordan in 2006 to that in 2007?
Keep it short and to the point. 0.93. What is the ratio of the Value (constant 2005 US$) in Japan in 2006 to that in 2008?
Your answer should be compact. 0.99. What is the ratio of the Value (constant 2005 US$) in Jordan in 2006 to that in 2008?
Make the answer very short. 0.75. What is the ratio of the Value (constant 2005 US$) of Bulgaria in 2006 to that in 2009?
Provide a short and direct response. 1.1. What is the ratio of the Value (constant 2005 US$) in Japan in 2006 to that in 2009?
Offer a terse response. 0.97. What is the ratio of the Value (constant 2005 US$) in Jordan in 2006 to that in 2009?
Offer a terse response. 0.68. What is the ratio of the Value (constant 2005 US$) of Bulgaria in 2006 to that in 2010?
Provide a succinct answer. 1.12. What is the ratio of the Value (constant 2005 US$) of Japan in 2006 to that in 2010?
Offer a terse response. 0.95. What is the ratio of the Value (constant 2005 US$) in Jordan in 2006 to that in 2010?
Keep it short and to the point. 0.77. What is the ratio of the Value (constant 2005 US$) in Japan in 2007 to that in 2008?
Keep it short and to the point. 1. What is the ratio of the Value (constant 2005 US$) of Jordan in 2007 to that in 2008?
Ensure brevity in your answer.  0.81. What is the ratio of the Value (constant 2005 US$) in Bulgaria in 2007 to that in 2009?
Provide a succinct answer. 1.11. What is the ratio of the Value (constant 2005 US$) in Japan in 2007 to that in 2009?
Provide a succinct answer. 0.98. What is the ratio of the Value (constant 2005 US$) of Jordan in 2007 to that in 2009?
Provide a short and direct response. 0.73. What is the ratio of the Value (constant 2005 US$) in Bulgaria in 2007 to that in 2010?
Provide a succinct answer. 1.13. What is the ratio of the Value (constant 2005 US$) of Japan in 2007 to that in 2010?
Your answer should be compact. 0.96. What is the ratio of the Value (constant 2005 US$) of Jordan in 2007 to that in 2010?
Keep it short and to the point. 0.83. What is the ratio of the Value (constant 2005 US$) of Bulgaria in 2008 to that in 2009?
Give a very brief answer. 1.1. What is the ratio of the Value (constant 2005 US$) in Japan in 2008 to that in 2009?
Provide a short and direct response. 0.98. What is the ratio of the Value (constant 2005 US$) in Jordan in 2008 to that in 2009?
Your response must be concise. 0.91. What is the ratio of the Value (constant 2005 US$) of Bulgaria in 2008 to that in 2010?
Make the answer very short. 1.13. What is the ratio of the Value (constant 2005 US$) in Japan in 2008 to that in 2010?
Ensure brevity in your answer.  0.96. What is the ratio of the Value (constant 2005 US$) in Jordan in 2008 to that in 2010?
Your answer should be very brief. 1.02. What is the ratio of the Value (constant 2005 US$) of Bulgaria in 2009 to that in 2010?
Offer a terse response. 1.02. What is the ratio of the Value (constant 2005 US$) of Japan in 2009 to that in 2010?
Offer a very short reply. 0.98. What is the ratio of the Value (constant 2005 US$) of Jordan in 2009 to that in 2010?
Provide a short and direct response. 1.13. What is the difference between the highest and the second highest Value (constant 2005 US$) in Bulgaria?
Make the answer very short. 8.86e+06. What is the difference between the highest and the second highest Value (constant 2005 US$) of Japan?
Offer a very short reply. 1.64e+1. What is the difference between the highest and the second highest Value (constant 2005 US$) of Jordan?
Your response must be concise. 3.93e+08. What is the difference between the highest and the lowest Value (constant 2005 US$) of Bulgaria?
Your answer should be very brief. 6.83e+08. What is the difference between the highest and the lowest Value (constant 2005 US$) in Japan?
Your answer should be compact. 6.32e+1. What is the difference between the highest and the lowest Value (constant 2005 US$) of Jordan?
Offer a very short reply. 1.69e+09. 